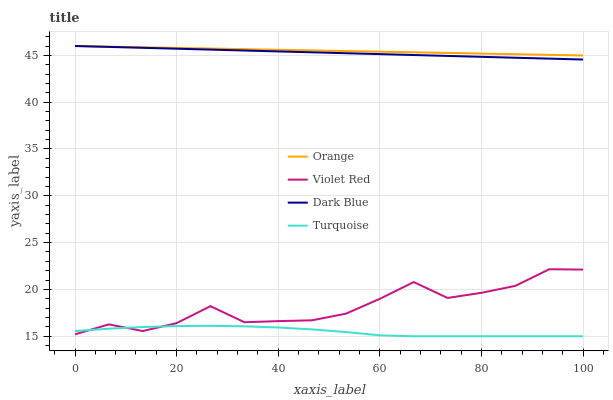Does Turquoise have the minimum area under the curve?
Answer yes or no. Yes. Does Orange have the maximum area under the curve?
Answer yes or no. Yes. Does Dark Blue have the minimum area under the curve?
Answer yes or no. No. Does Dark Blue have the maximum area under the curve?
Answer yes or no. No. Is Orange the smoothest?
Answer yes or no. Yes. Is Violet Red the roughest?
Answer yes or no. Yes. Is Dark Blue the smoothest?
Answer yes or no. No. Is Dark Blue the roughest?
Answer yes or no. No. Does Turquoise have the lowest value?
Answer yes or no. Yes. Does Dark Blue have the lowest value?
Answer yes or no. No. Does Dark Blue have the highest value?
Answer yes or no. Yes. Does Violet Red have the highest value?
Answer yes or no. No. Is Turquoise less than Dark Blue?
Answer yes or no. Yes. Is Dark Blue greater than Violet Red?
Answer yes or no. Yes. Does Dark Blue intersect Orange?
Answer yes or no. Yes. Is Dark Blue less than Orange?
Answer yes or no. No. Is Dark Blue greater than Orange?
Answer yes or no. No. Does Turquoise intersect Dark Blue?
Answer yes or no. No. 